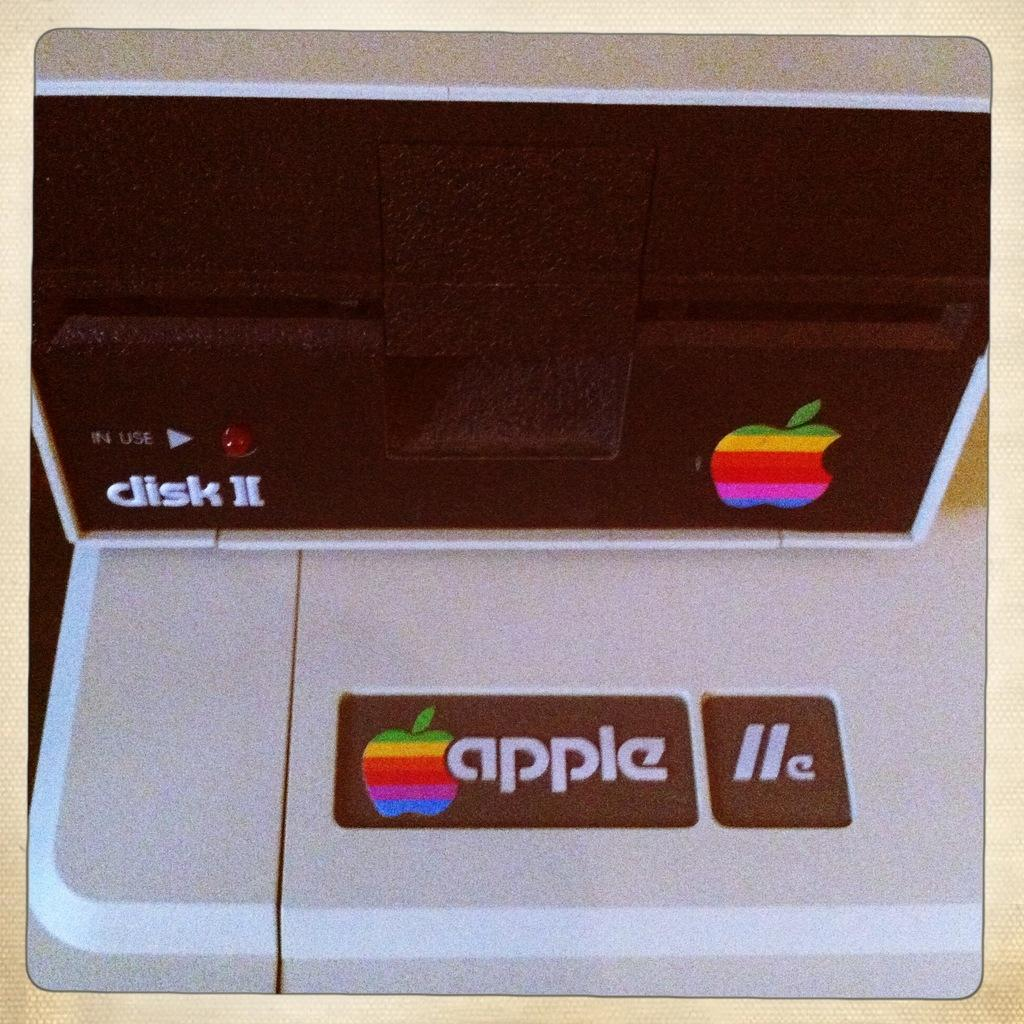Provide a one-sentence caption for the provided image. An Apple IIe disk drive has a multi colored apple as its logo. 